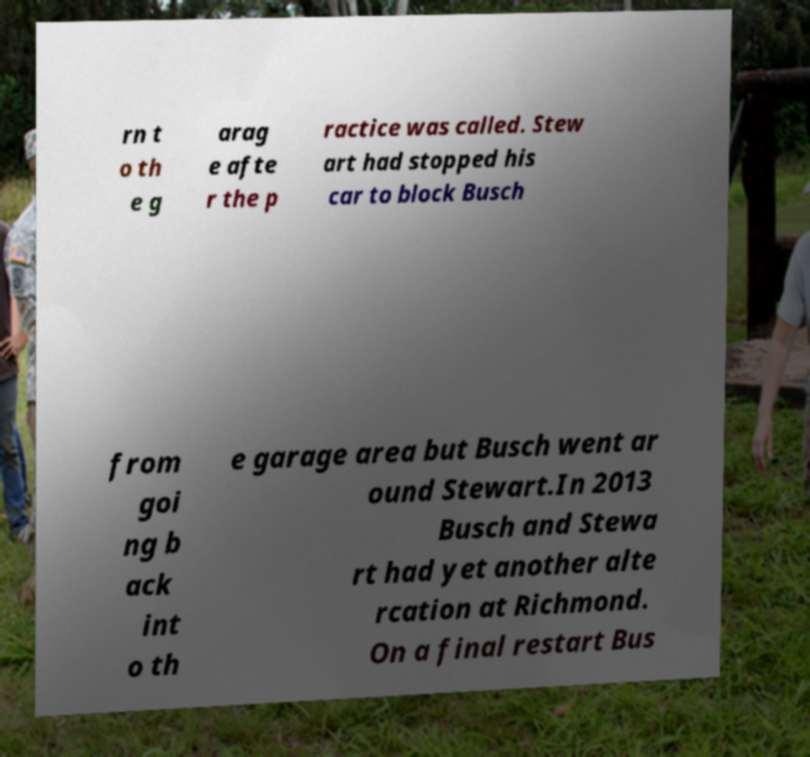What messages or text are displayed in this image? I need them in a readable, typed format. rn t o th e g arag e afte r the p ractice was called. Stew art had stopped his car to block Busch from goi ng b ack int o th e garage area but Busch went ar ound Stewart.In 2013 Busch and Stewa rt had yet another alte rcation at Richmond. On a final restart Bus 